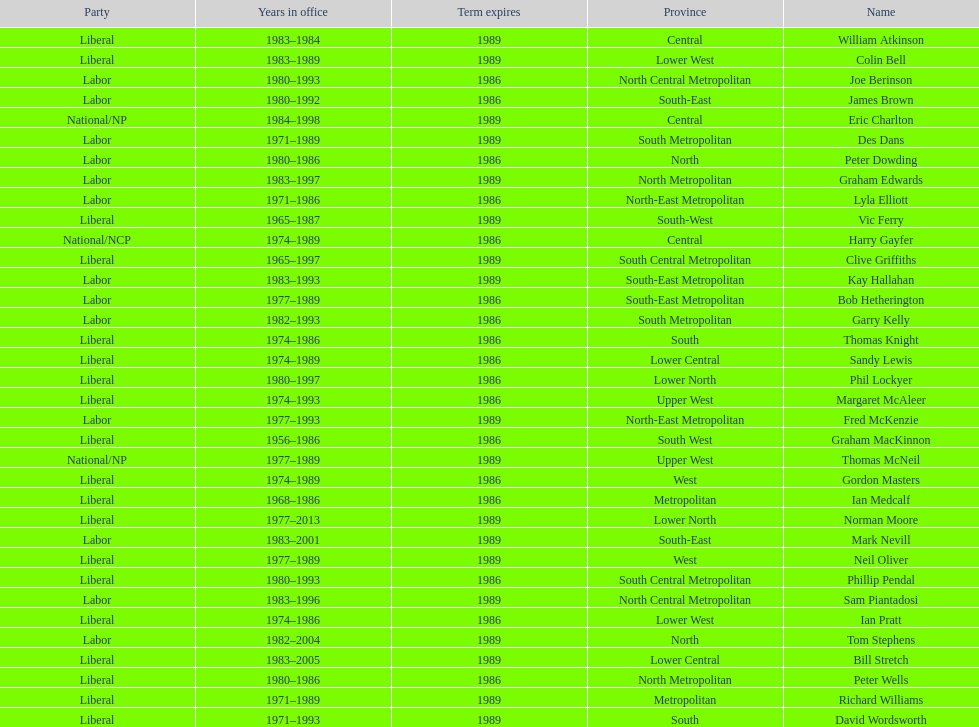Who has had the shortest term in office William Atkinson. Parse the full table. {'header': ['Party', 'Years in office', 'Term expires', 'Province', 'Name'], 'rows': [['Liberal', '1983–1984', '1989', 'Central', 'William Atkinson'], ['Liberal', '1983–1989', '1989', 'Lower West', 'Colin Bell'], ['Labor', '1980–1993', '1986', 'North Central Metropolitan', 'Joe Berinson'], ['Labor', '1980–1992', '1986', 'South-East', 'James Brown'], ['National/NP', '1984–1998', '1989', 'Central', 'Eric Charlton'], ['Labor', '1971–1989', '1989', 'South Metropolitan', 'Des Dans'], ['Labor', '1980–1986', '1986', 'North', 'Peter Dowding'], ['Labor', '1983–1997', '1989', 'North Metropolitan', 'Graham Edwards'], ['Labor', '1971–1986', '1986', 'North-East Metropolitan', 'Lyla Elliott'], ['Liberal', '1965–1987', '1989', 'South-West', 'Vic Ferry'], ['National/NCP', '1974–1989', '1986', 'Central', 'Harry Gayfer'], ['Liberal', '1965–1997', '1989', 'South Central Metropolitan', 'Clive Griffiths'], ['Labor', '1983–1993', '1989', 'South-East Metropolitan', 'Kay Hallahan'], ['Labor', '1977–1989', '1986', 'South-East Metropolitan', 'Bob Hetherington'], ['Labor', '1982–1993', '1986', 'South Metropolitan', 'Garry Kelly'], ['Liberal', '1974–1986', '1986', 'South', 'Thomas Knight'], ['Liberal', '1974–1989', '1986', 'Lower Central', 'Sandy Lewis'], ['Liberal', '1980–1997', '1986', 'Lower North', 'Phil Lockyer'], ['Liberal', '1974–1993', '1986', 'Upper West', 'Margaret McAleer'], ['Labor', '1977–1993', '1989', 'North-East Metropolitan', 'Fred McKenzie'], ['Liberal', '1956–1986', '1986', 'South West', 'Graham MacKinnon'], ['National/NP', '1977–1989', '1989', 'Upper West', 'Thomas McNeil'], ['Liberal', '1974–1989', '1986', 'West', 'Gordon Masters'], ['Liberal', '1968–1986', '1986', 'Metropolitan', 'Ian Medcalf'], ['Liberal', '1977–2013', '1989', 'Lower North', 'Norman Moore'], ['Labor', '1983–2001', '1989', 'South-East', 'Mark Nevill'], ['Liberal', '1977–1989', '1989', 'West', 'Neil Oliver'], ['Liberal', '1980–1993', '1986', 'South Central Metropolitan', 'Phillip Pendal'], ['Labor', '1983–1996', '1989', 'North Central Metropolitan', 'Sam Piantadosi'], ['Liberal', '1974–1986', '1986', 'Lower West', 'Ian Pratt'], ['Labor', '1982–2004', '1989', 'North', 'Tom Stephens'], ['Liberal', '1983–2005', '1989', 'Lower Central', 'Bill Stretch'], ['Liberal', '1980–1986', '1986', 'North Metropolitan', 'Peter Wells'], ['Liberal', '1971–1989', '1989', 'Metropolitan', 'Richard Williams'], ['Liberal', '1971–1993', '1989', 'South', 'David Wordsworth']]} 